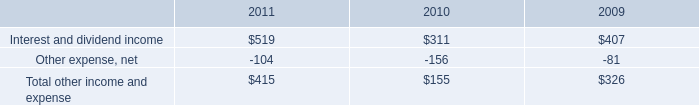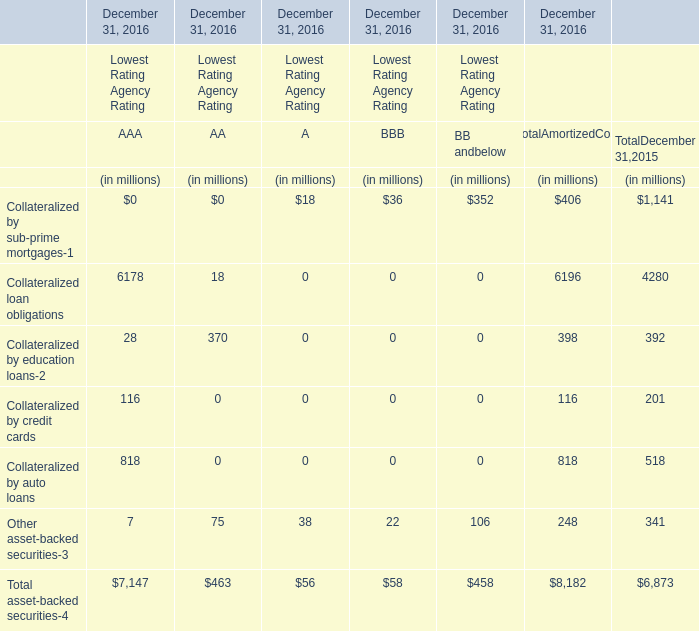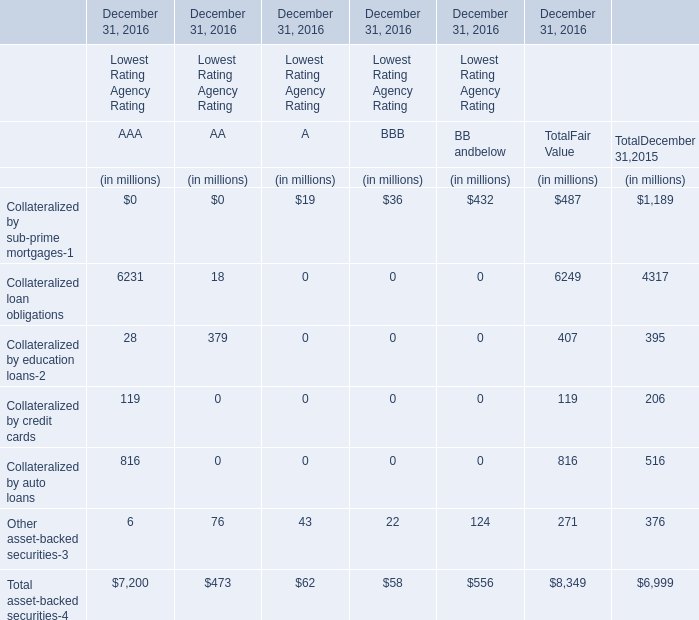What do all AA of Lowest Rating Agency Rating sum up, excluding those negative ones in 2016 for December 31, 2016 ? (in million) 
Computations: (((((18 + 370) + 75) + 0) + 0) + 0)
Answer: 463.0. 